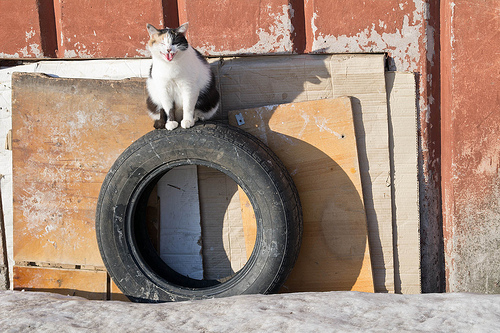<image>
Can you confirm if the cat is on the wheel? Yes. Looking at the image, I can see the cat is positioned on top of the wheel, with the wheel providing support. Is there a wall to the left of the tire? No. The wall is not to the left of the tire. From this viewpoint, they have a different horizontal relationship. 